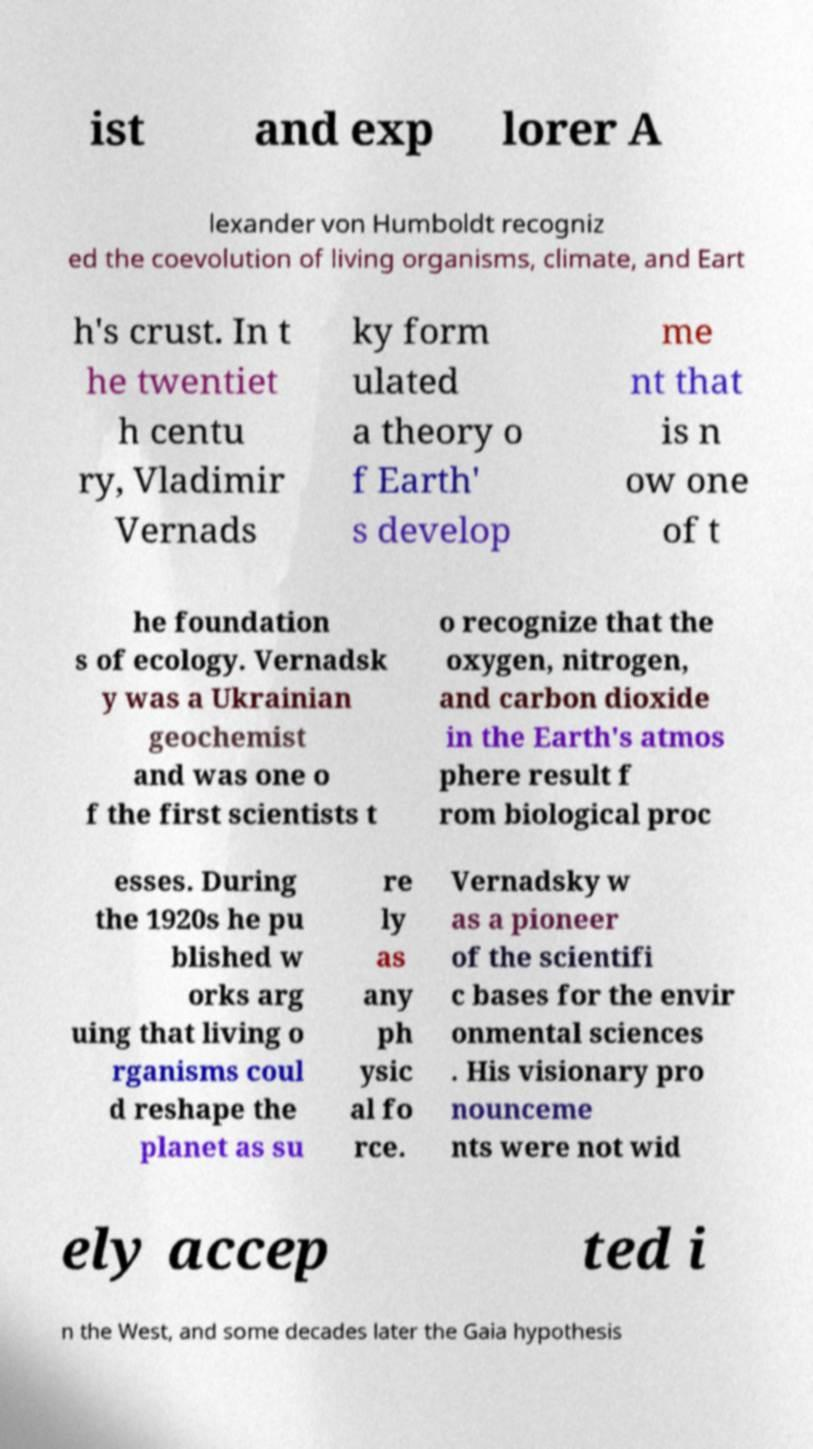What messages or text are displayed in this image? I need them in a readable, typed format. ist and exp lorer A lexander von Humboldt recogniz ed the coevolution of living organisms, climate, and Eart h's crust. In t he twentiet h centu ry, Vladimir Vernads ky form ulated a theory o f Earth' s develop me nt that is n ow one of t he foundation s of ecology. Vernadsk y was a Ukrainian geochemist and was one o f the first scientists t o recognize that the oxygen, nitrogen, and carbon dioxide in the Earth's atmos phere result f rom biological proc esses. During the 1920s he pu blished w orks arg uing that living o rganisms coul d reshape the planet as su re ly as any ph ysic al fo rce. Vernadsky w as a pioneer of the scientifi c bases for the envir onmental sciences . His visionary pro nounceme nts were not wid ely accep ted i n the West, and some decades later the Gaia hypothesis 